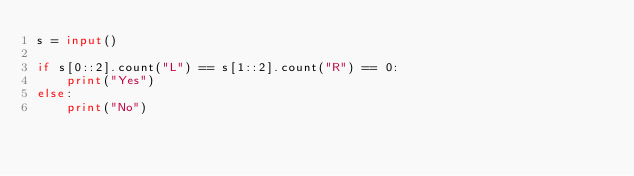Convert code to text. <code><loc_0><loc_0><loc_500><loc_500><_Python_>s = input()

if s[0::2].count("L") == s[1::2].count("R") == 0:
    print("Yes")
else:
    print("No")</code> 